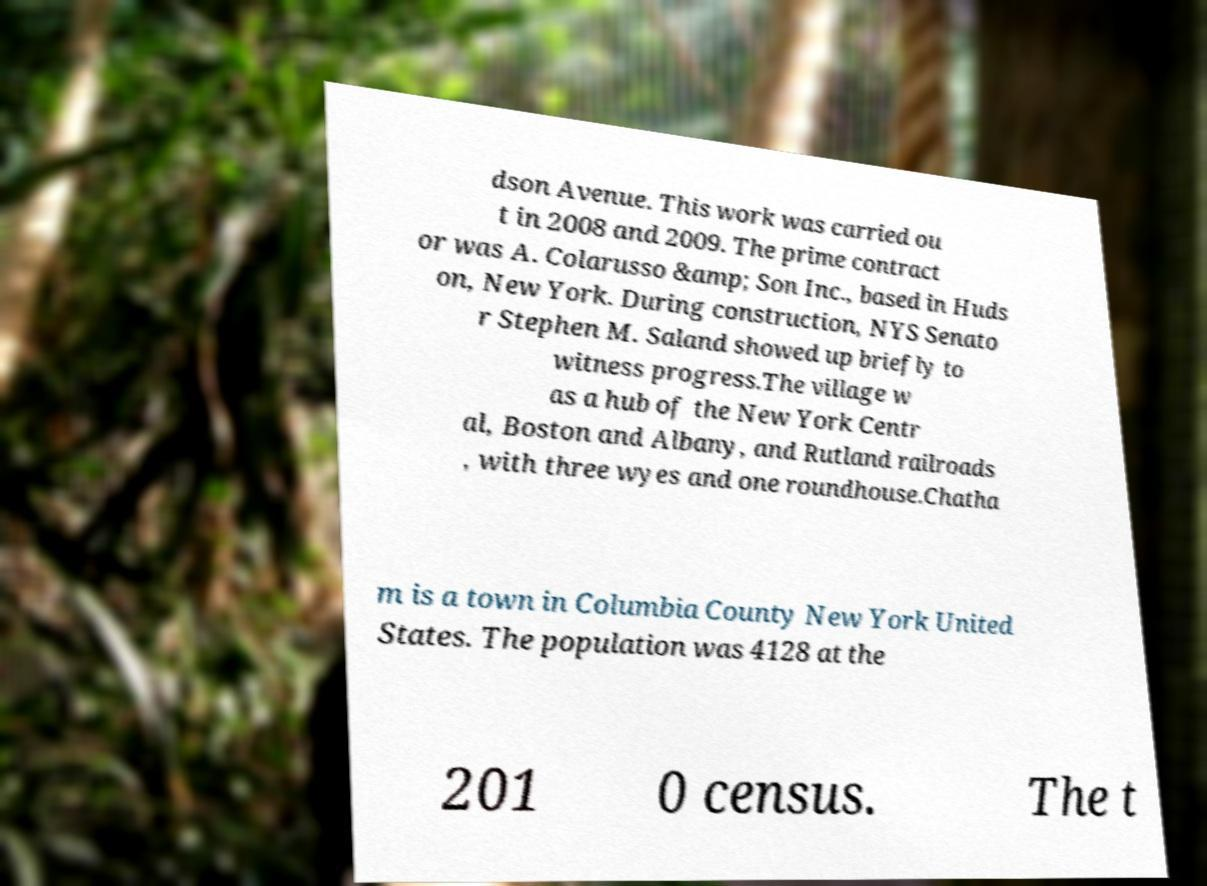There's text embedded in this image that I need extracted. Can you transcribe it verbatim? dson Avenue. This work was carried ou t in 2008 and 2009. The prime contract or was A. Colarusso &amp; Son Inc., based in Huds on, New York. During construction, NYS Senato r Stephen M. Saland showed up briefly to witness progress.The village w as a hub of the New York Centr al, Boston and Albany, and Rutland railroads , with three wyes and one roundhouse.Chatha m is a town in Columbia County New York United States. The population was 4128 at the 201 0 census. The t 